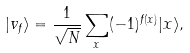<formula> <loc_0><loc_0><loc_500><loc_500>| v _ { f } \rangle = \frac { 1 } { \sqrt { N } } \sum _ { x } ( - 1 ) ^ { f ( x ) } | x \rangle ,</formula> 